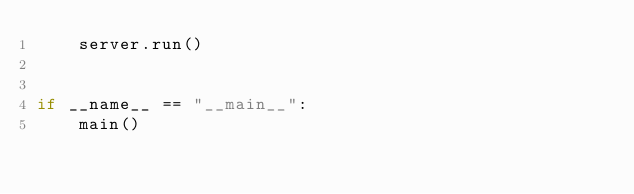<code> <loc_0><loc_0><loc_500><loc_500><_Python_>    server.run()


if __name__ == "__main__":
    main()
</code> 